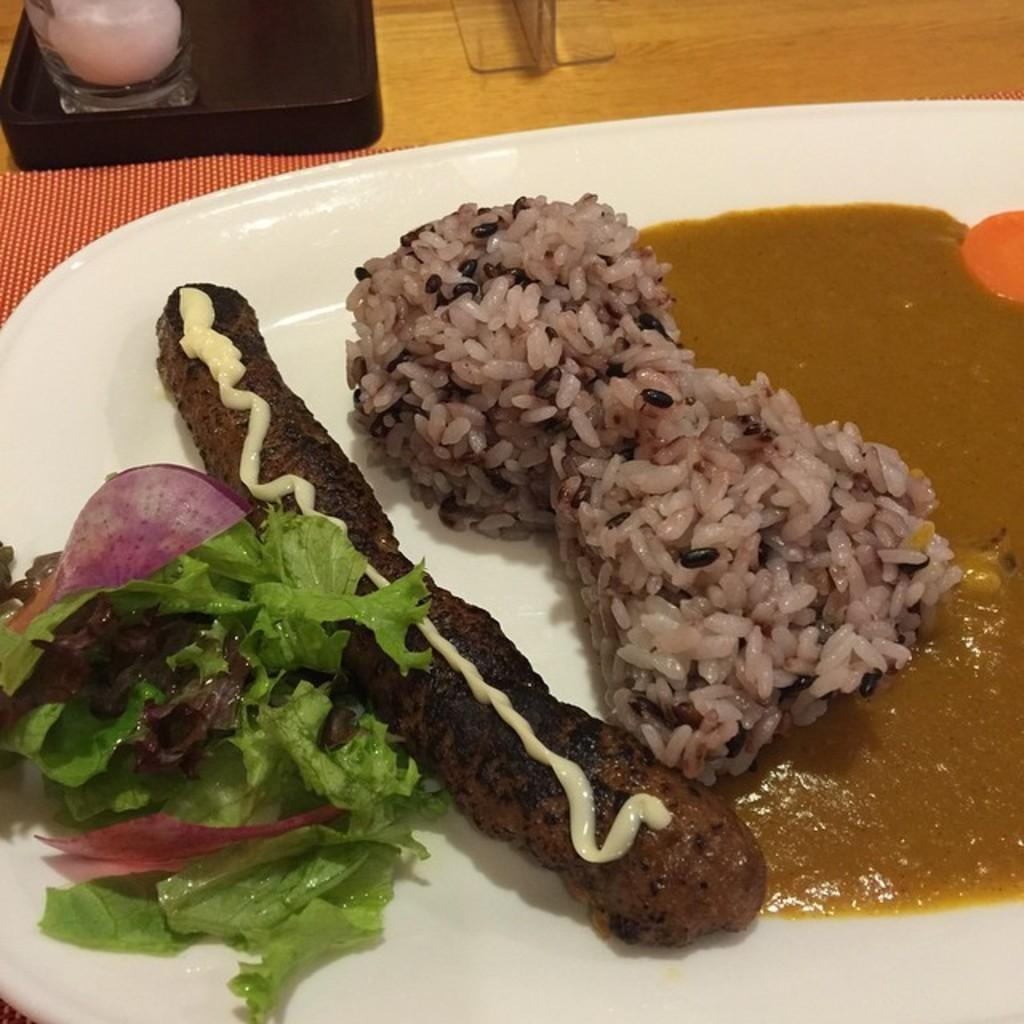What type of food can be seen in the image? There is rice, gravy, and a green salad in the image. What else is present on the plate in the image? There is another food item on a plate in the image. Where is the plate located? The plate is on top of a table. What can be seen beside the plate on the table? There are condiments beside the plate in the image. What type of account is being discussed in the image? There is no account or financial information present in the image; it features food items on a plate with condiments. 